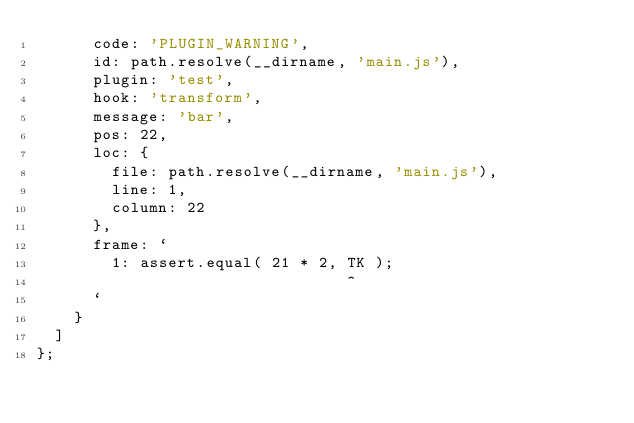<code> <loc_0><loc_0><loc_500><loc_500><_JavaScript_>			code: 'PLUGIN_WARNING',
			id: path.resolve(__dirname, 'main.js'),
			plugin: 'test',
			hook: 'transform',
			message: 'bar',
			pos: 22,
			loc: {
				file: path.resolve(__dirname, 'main.js'),
				line: 1,
				column: 22
			},
			frame: `
				1: assert.equal( 21 * 2, TK );
				                         ^
			`
		}
	]
};
</code> 